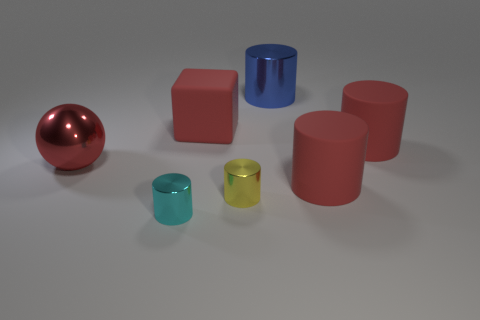Subtract all yellow cylinders. How many cylinders are left? 4 Subtract all green cylinders. Subtract all blue balls. How many cylinders are left? 5 Add 2 large purple metal objects. How many objects exist? 9 Subtract all cylinders. How many objects are left? 2 Add 7 balls. How many balls are left? 8 Add 3 small cyan metal cylinders. How many small cyan metal cylinders exist? 4 Subtract 0 green cylinders. How many objects are left? 7 Subtract all large balls. Subtract all large metallic spheres. How many objects are left? 5 